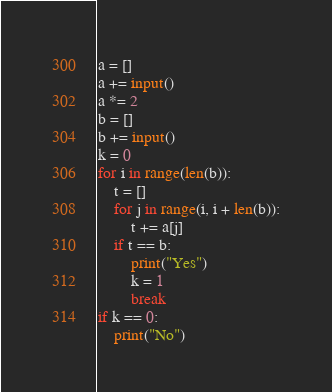Convert code to text. <code><loc_0><loc_0><loc_500><loc_500><_Python_>a = []
a += input()
a *= 2
b = []
b += input()
k = 0
for i in range(len(b)):
    t = []
    for j in range(i, i + len(b)):
        t += a[j]
    if t == b:
        print("Yes")
        k = 1
        break
if k == 0:
    print("No")</code> 